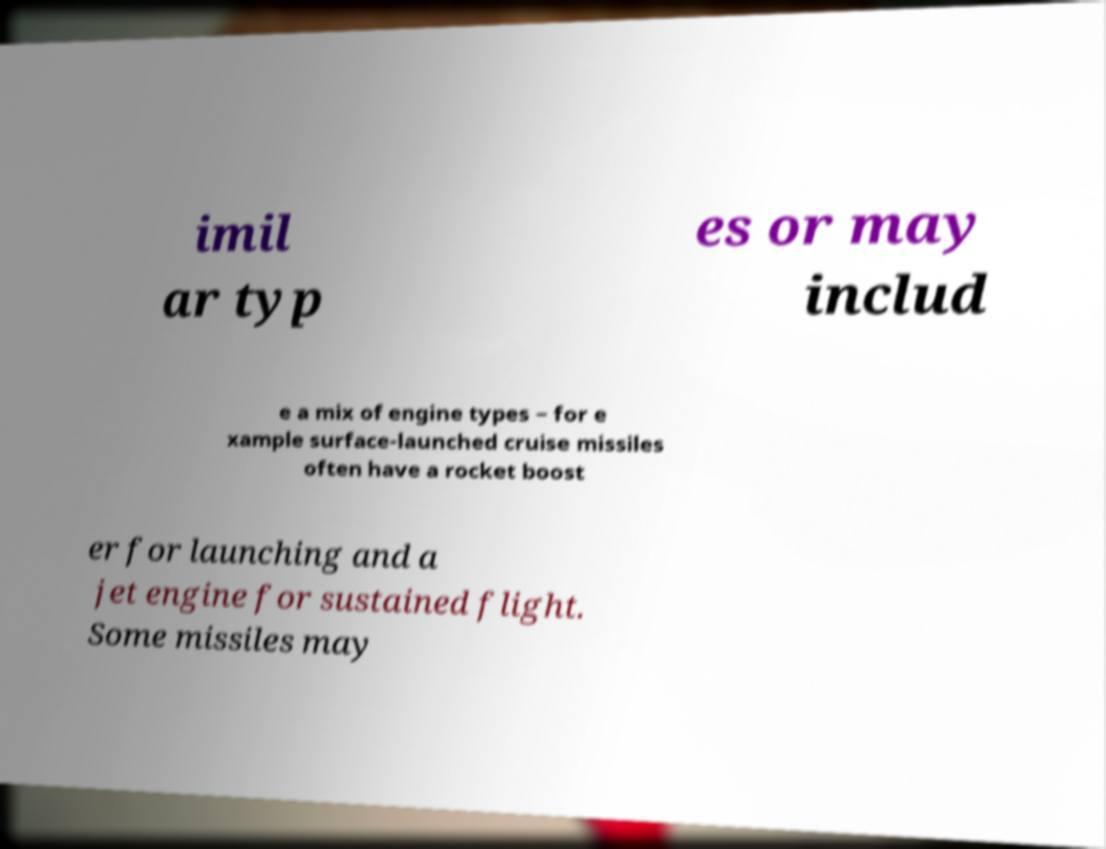I need the written content from this picture converted into text. Can you do that? imil ar typ es or may includ e a mix of engine types − for e xample surface-launched cruise missiles often have a rocket boost er for launching and a jet engine for sustained flight. Some missiles may 